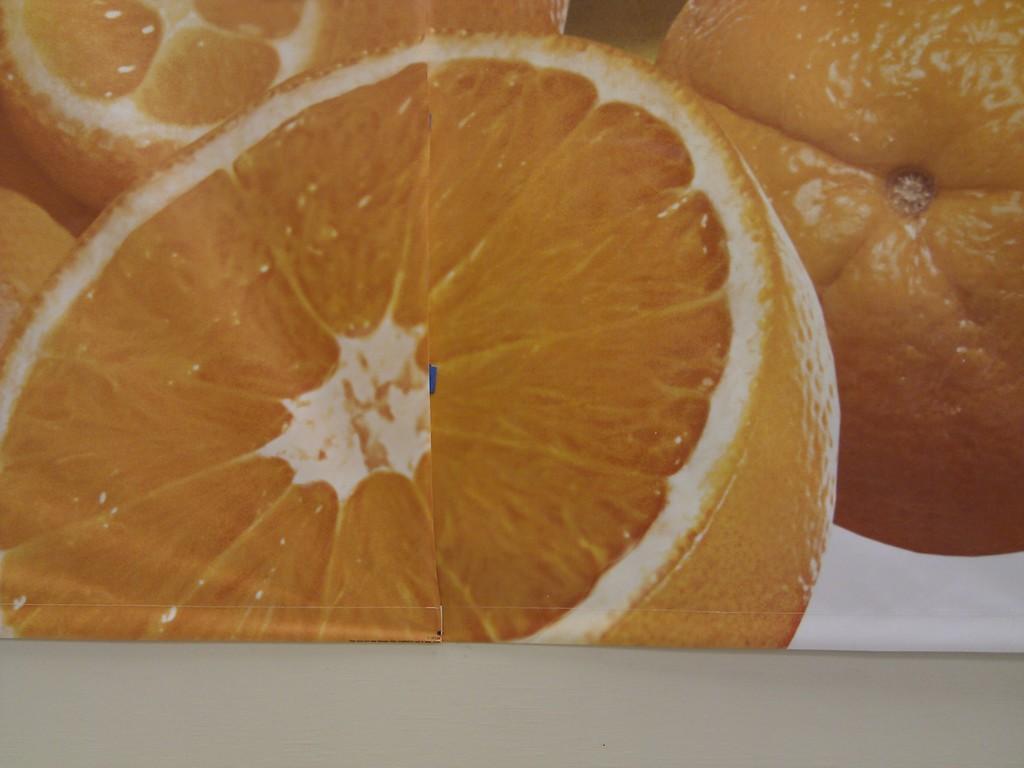Can you describe this image briefly? This is a zoomed in picture. In the foreground there is a white color object. In the center we can see the sliced oranges. On the right there is an orange seems to be placed on the surface of an object. 